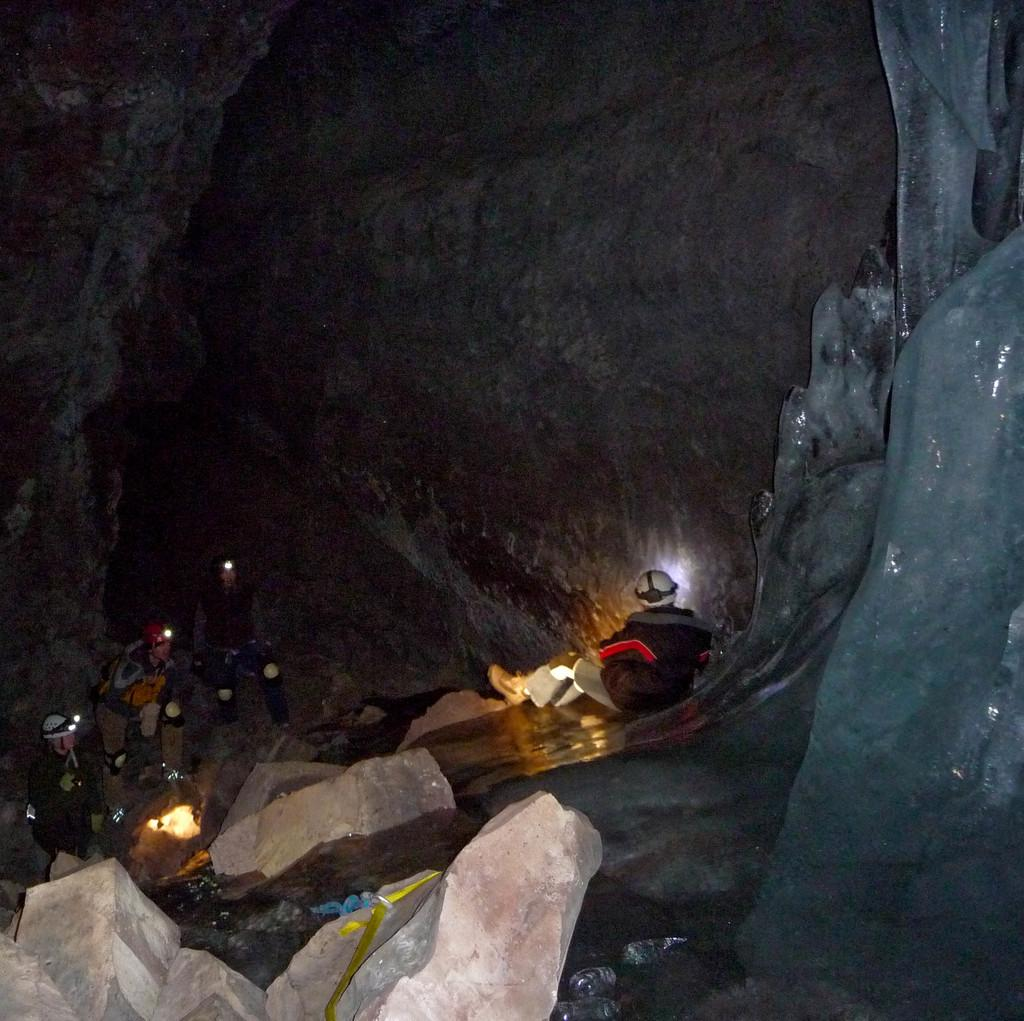What type of natural formation is present in the image? There is a cave in the image. Are there any living beings visible in the image? Yes, there are people in the image. What other geological features can be seen in the image? There are rocks in the image. What type of cherry is being used to decorate the cave in the image? There is no cherry present in the image, and the cave is not being decorated with any fruit. 